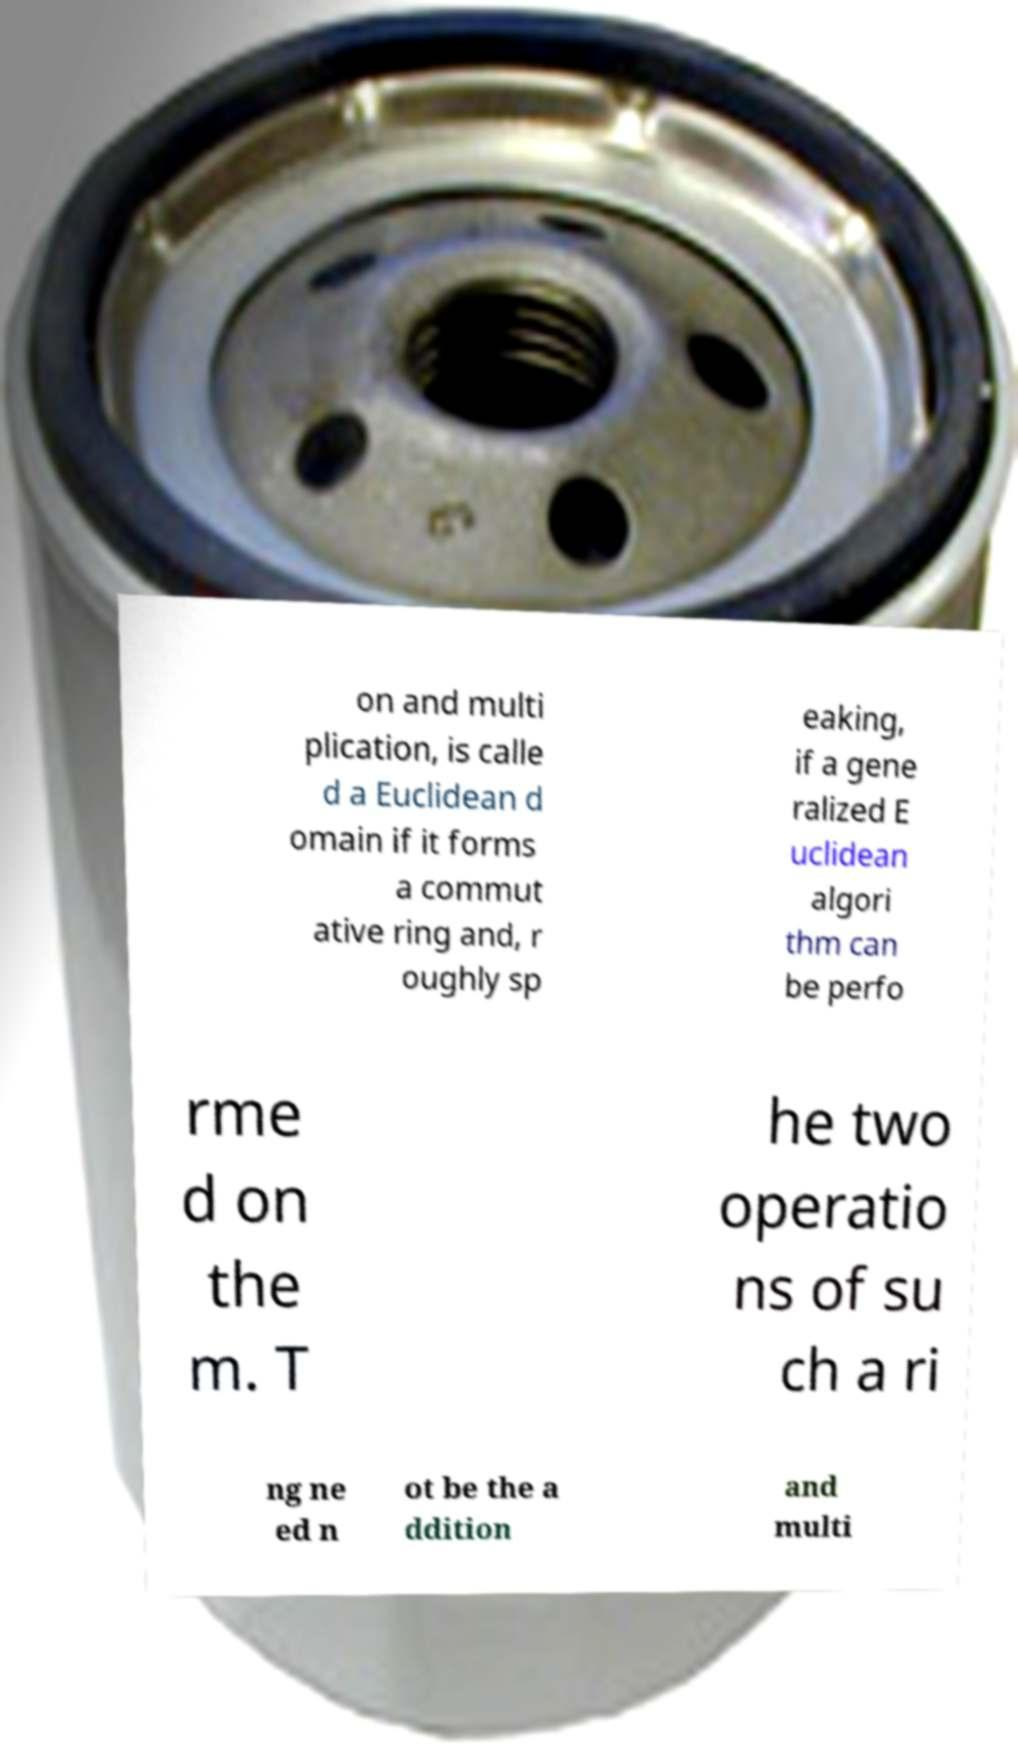Can you read and provide the text displayed in the image?This photo seems to have some interesting text. Can you extract and type it out for me? on and multi plication, is calle d a Euclidean d omain if it forms a commut ative ring and, r oughly sp eaking, if a gene ralized E uclidean algori thm can be perfo rme d on the m. T he two operatio ns of su ch a ri ng ne ed n ot be the a ddition and multi 